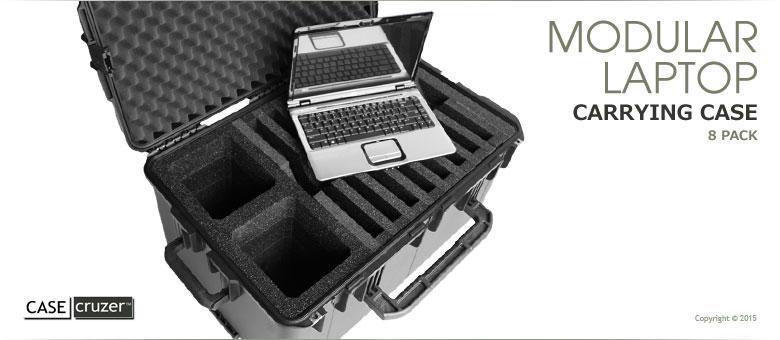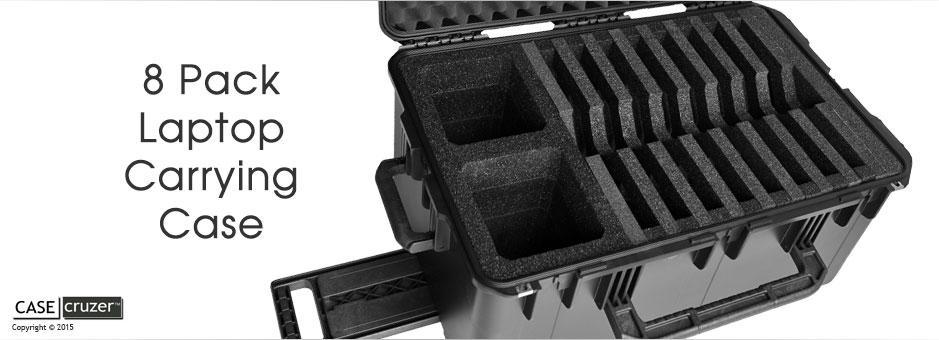The first image is the image on the left, the second image is the image on the right. Considering the images on both sides, is "A carrying case stands upright and closed with another case in one of the images." valid? Answer yes or no. No. The first image is the image on the left, the second image is the image on the right. Assess this claim about the two images: "One of the cases shown is closed, standing upright, and has a handle sticking out of the top for pushing or pulling the case.". Correct or not? Answer yes or no. No. 